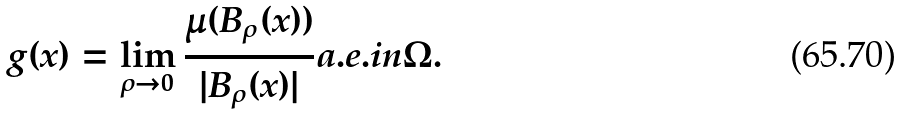Convert formula to latex. <formula><loc_0><loc_0><loc_500><loc_500>g ( x ) = \lim _ { \rho \to 0 } \frac { \mu ( B _ { \rho } ( x ) ) } { | B _ { \rho } ( x ) | } a . e . i n \Omega .</formula> 